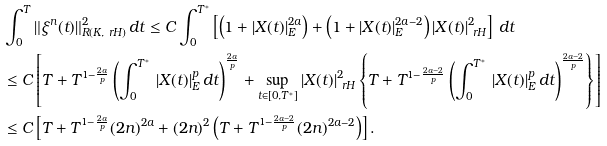Convert formula to latex. <formula><loc_0><loc_0><loc_500><loc_500>& \int _ { 0 } ^ { T } \| \xi ^ { n } ( t ) \| _ { R ( K , \ r H ) } ^ { 2 } \, d t \leq C \int _ { 0 } ^ { T ^ { \ast } } \left [ \left ( 1 + | X ( t ) | ^ { 2 a } _ { E } \right ) + \left ( 1 + | X ( t ) | ^ { 2 a - 2 } _ { E } \right ) | X ( t ) | ^ { 2 } _ { \ r H } \right ] \, d t \\ & \leq C \left [ T + T ^ { 1 - \frac { 2 a } p } \left ( \int _ { 0 } ^ { T ^ { \ast } } \, | X ( t ) | ^ { p } _ { E } \, d t \right ) ^ { \frac { 2 a } p } + \sup _ { t \in [ 0 , T ^ { \ast } ] } | X ( t ) | ^ { 2 } _ { \ r H } \left \{ T + T ^ { 1 - \frac { 2 a - 2 } p } \left ( \int _ { 0 } ^ { T ^ { \ast } } \, | X ( t ) | ^ { p } _ { E } \, d t \right ) ^ { \frac { 2 a - 2 } p } \right \} \right ] \\ & \leq C \left [ T + T ^ { 1 - \frac { 2 a } p } ( 2 n ) ^ { 2 a } + ( 2 n ) ^ { 2 } \left ( T + T ^ { 1 - \frac { 2 a - 2 } p } ( 2 n ) ^ { 2 a - 2 } \right ) \right ] .</formula> 